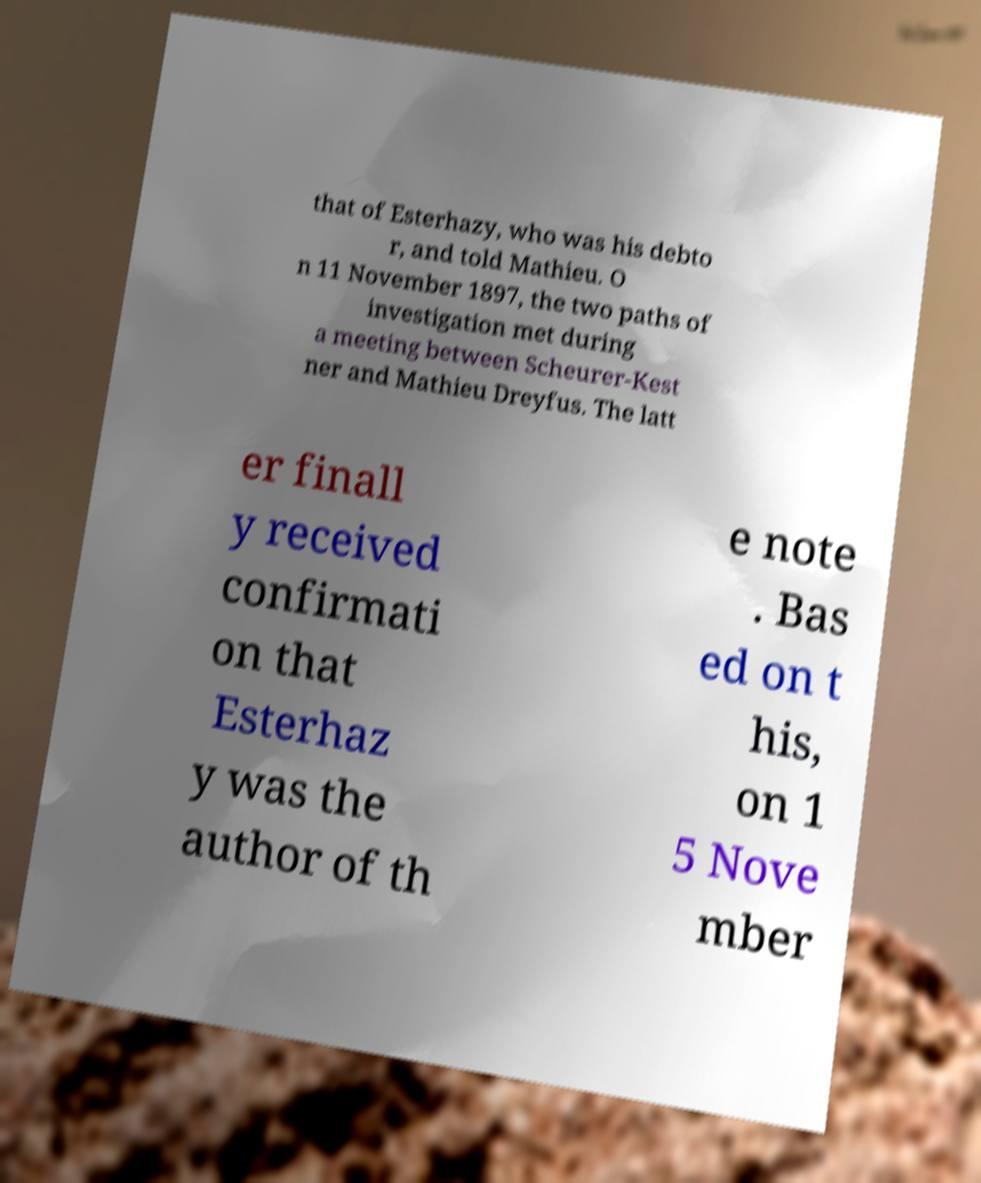Please identify and transcribe the text found in this image. that of Esterhazy, who was his debto r, and told Mathieu. O n 11 November 1897, the two paths of investigation met during a meeting between Scheurer-Kest ner and Mathieu Dreyfus. The latt er finall y received confirmati on that Esterhaz y was the author of th e note . Bas ed on t his, on 1 5 Nove mber 